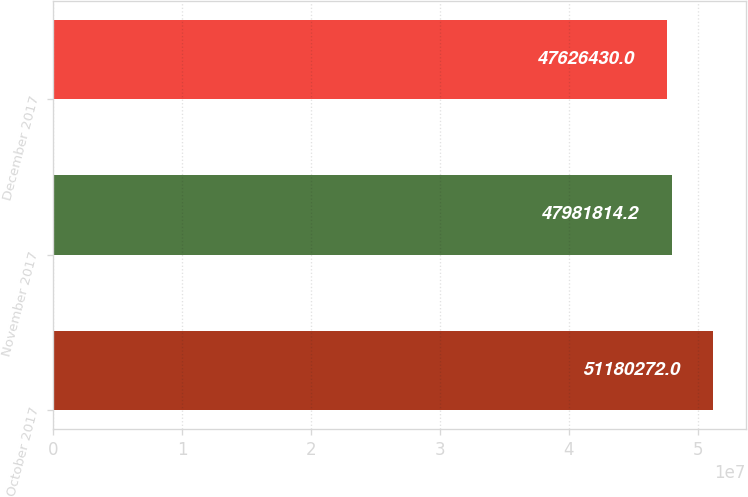Convert chart to OTSL. <chart><loc_0><loc_0><loc_500><loc_500><bar_chart><fcel>October 2017<fcel>November 2017<fcel>December 2017<nl><fcel>5.11803e+07<fcel>4.79818e+07<fcel>4.76264e+07<nl></chart> 